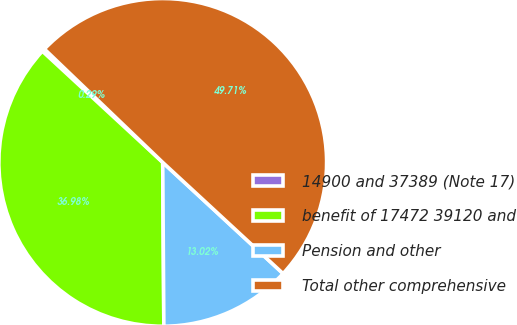Convert chart to OTSL. <chart><loc_0><loc_0><loc_500><loc_500><pie_chart><fcel>14900 and 37389 (Note 17)<fcel>benefit of 17472 39120 and<fcel>Pension and other<fcel>Total other comprehensive<nl><fcel>0.29%<fcel>36.98%<fcel>13.02%<fcel>49.71%<nl></chart> 